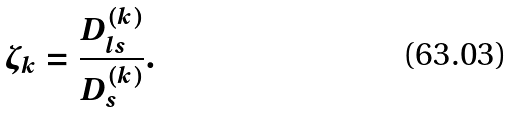Convert formula to latex. <formula><loc_0><loc_0><loc_500><loc_500>\zeta _ { k } = \frac { D _ { l s } ^ { ( k ) } } { D _ { s } ^ { ( k ) } } .</formula> 